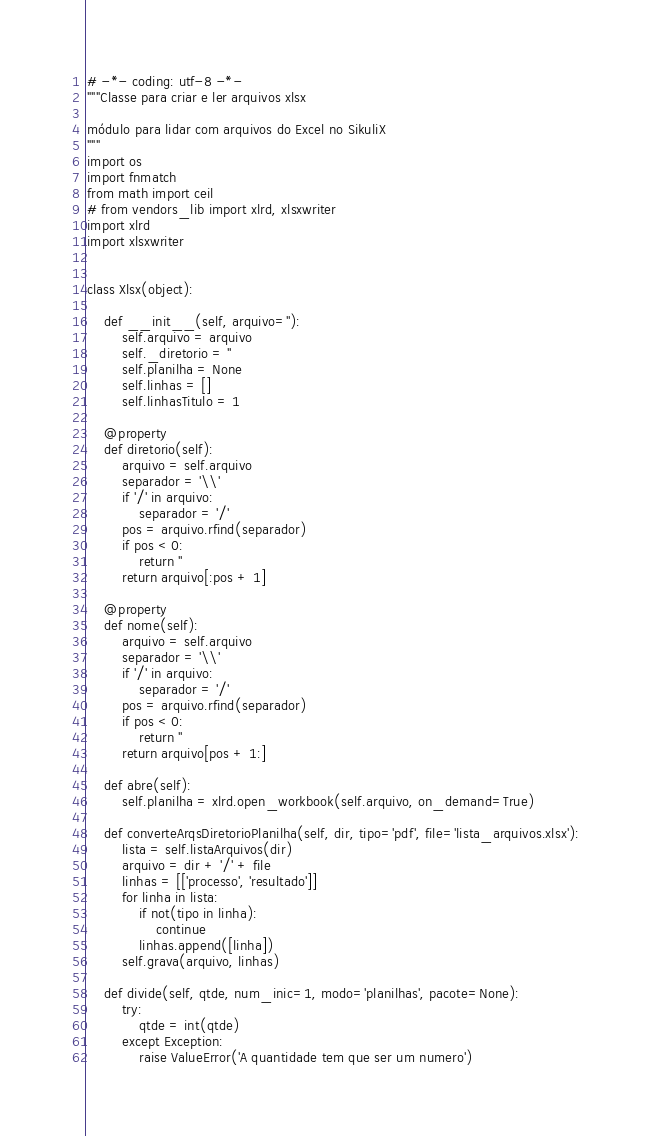<code> <loc_0><loc_0><loc_500><loc_500><_Python_># -*- coding: utf-8 -*-
"""Classe para criar e ler arquivos xlsx

módulo para lidar com arquivos do Excel no SikuliX
"""
import os
import fnmatch
from math import ceil
# from vendors_lib import xlrd, xlsxwriter
import xlrd
import xlsxwriter


class Xlsx(object):

    def __init__(self, arquivo=''):
        self.arquivo = arquivo
        self._diretorio = ''
        self.planilha = None
        self.linhas = []
        self.linhasTitulo = 1

    @property
    def diretorio(self):
        arquivo = self.arquivo
        separador = '\\'
        if '/' in arquivo:
            separador = '/'
        pos = arquivo.rfind(separador)
        if pos < 0:
            return ''
        return arquivo[:pos + 1]

    @property
    def nome(self):
        arquivo = self.arquivo
        separador = '\\'
        if '/' in arquivo:
            separador = '/'
        pos = arquivo.rfind(separador)
        if pos < 0:
            return ''
        return arquivo[pos + 1:]

    def abre(self):
        self.planilha = xlrd.open_workbook(self.arquivo, on_demand=True)

    def converteArqsDiretorioPlanilha(self, dir, tipo='pdf', file='lista_arquivos.xlsx'):
        lista = self.listaArquivos(dir)
        arquivo = dir + '/' + file
        linhas = [['processo', 'resultado']]
        for linha in lista:
            if not(tipo in linha):
                continue
            linhas.append([linha])
        self.grava(arquivo, linhas)

    def divide(self, qtde, num_inic=1, modo='planilhas', pacote=None):
        try:
            qtde = int(qtde)
        except Exception:
            raise ValueError('A quantidade tem que ser um numero')</code> 